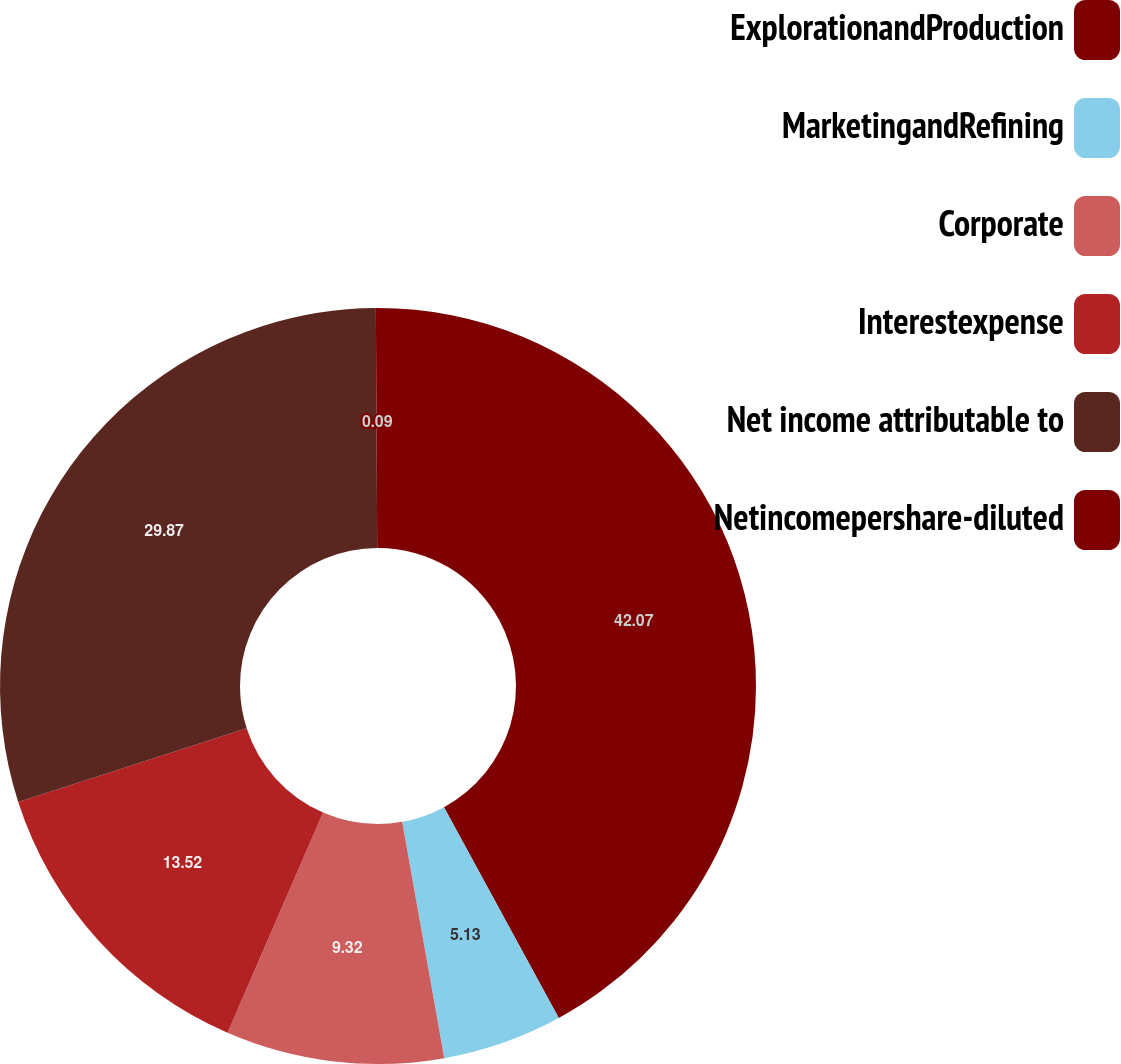<chart> <loc_0><loc_0><loc_500><loc_500><pie_chart><fcel>ExplorationandProduction<fcel>MarketingandRefining<fcel>Corporate<fcel>Interestexpense<fcel>Net income attributable to<fcel>Netincomepershare-diluted<nl><fcel>42.06%<fcel>5.13%<fcel>9.32%<fcel>13.52%<fcel>29.87%<fcel>0.09%<nl></chart> 